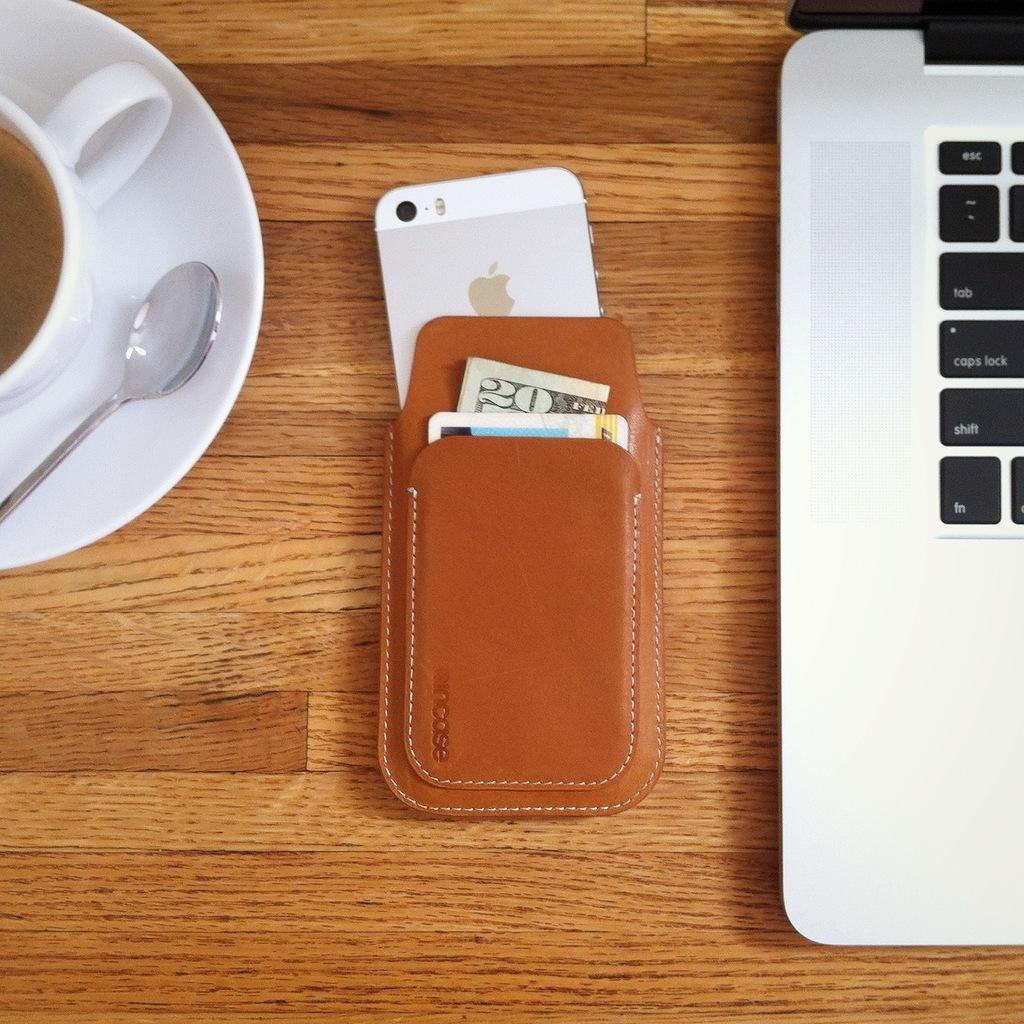What is in the cup that is visible in the image? There is a drink in the cup in the image. What utensil is present in the image? There is a spoon in the image. What is the saucer used for in the image? The saucer is likely used to hold the cup or catch any spills. What type of device is present in the image? There is a mobile and a laptop in the image. What accessory is present in the image? There is a purse in the image. On what surface are the objects placed in the image? The objects are placed on a wooden table in the image. What is the price of the laptop in the image? The price of the laptop is not visible in the image, as it does not provide any information about the cost of the device. Can you describe the argument between the cup and the spoon in the image? There is no argument between the cup and the spoon in the image, as these are inanimate objects and cannot engage in such behavior. 